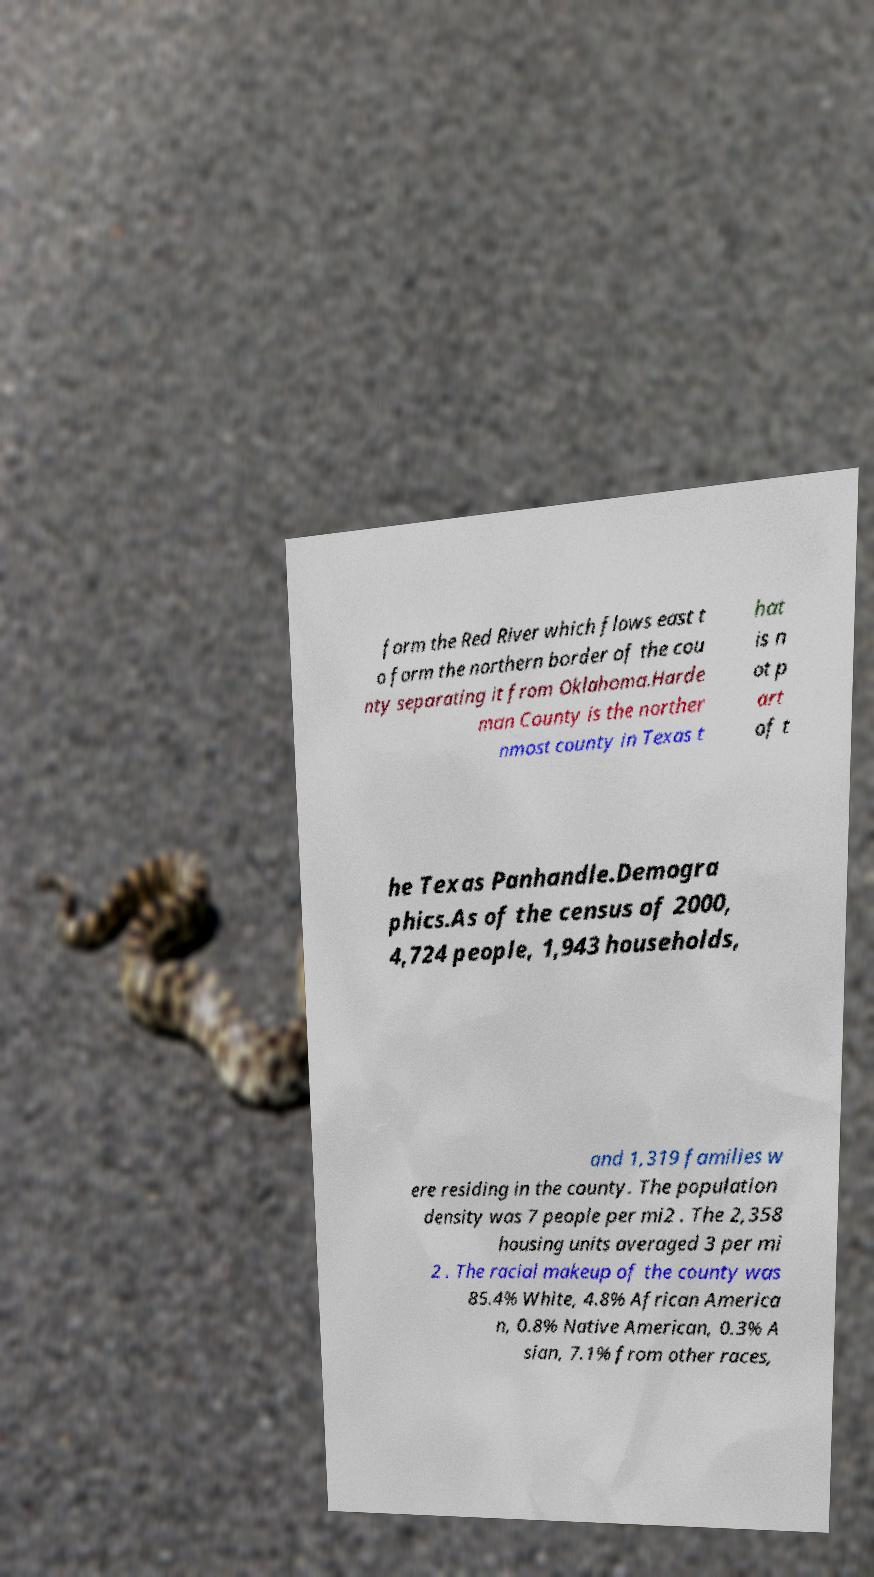Could you extract and type out the text from this image? form the Red River which flows east t o form the northern border of the cou nty separating it from Oklahoma.Harde man County is the norther nmost county in Texas t hat is n ot p art of t he Texas Panhandle.Demogra phics.As of the census of 2000, 4,724 people, 1,943 households, and 1,319 families w ere residing in the county. The population density was 7 people per mi2 . The 2,358 housing units averaged 3 per mi 2 . The racial makeup of the county was 85.4% White, 4.8% African America n, 0.8% Native American, 0.3% A sian, 7.1% from other races, 